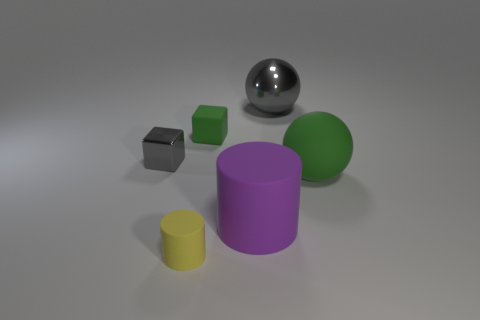There is a rubber thing behind the small gray metal cube; is its color the same as the rubber ball?
Keep it short and to the point. Yes. Do the purple cylinder and the rubber sphere have the same size?
Keep it short and to the point. Yes. Does the shiny sphere have the same color as the tiny block in front of the tiny rubber block?
Your response must be concise. Yes. There is a large object that is the same material as the gray cube; what shape is it?
Give a very brief answer. Sphere. Does the small matte object that is behind the tiny metallic cube have the same shape as the tiny gray metallic object?
Give a very brief answer. Yes. There is a green object to the left of the ball that is behind the small gray cube; what size is it?
Your answer should be very brief. Small. What is the color of the big ball that is made of the same material as the purple thing?
Your response must be concise. Green. What number of red cylinders are the same size as the purple matte object?
Your answer should be very brief. 0. How many cyan things are either small things or metal spheres?
Provide a short and direct response. 0. What number of objects are small green cubes or big objects that are in front of the tiny green matte object?
Provide a succinct answer. 3. 